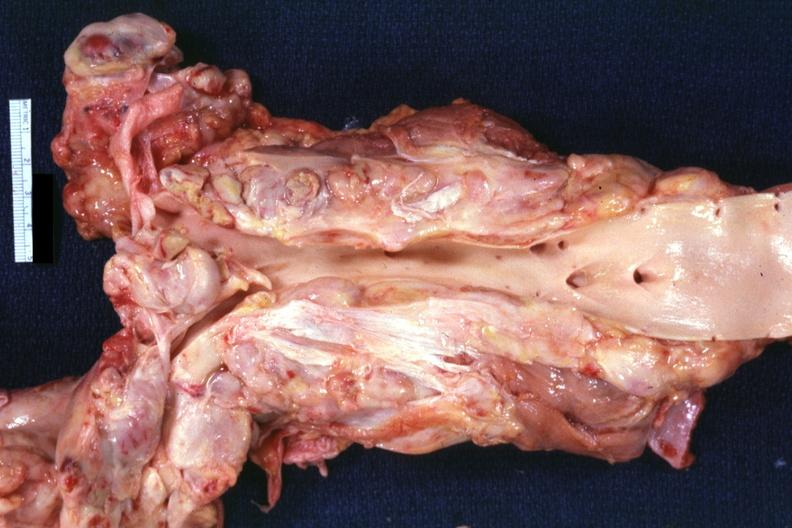what does this image show?
Answer the question using a single word or phrase. Opened aorta surrounded by enlarge nodes 